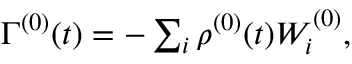<formula> <loc_0><loc_0><loc_500><loc_500>\begin{array} { r } { \Gamma ^ { ( 0 ) } ( t ) = - \sum _ { i } \rho ^ { ( 0 ) } ( t ) W _ { i } ^ { ( 0 ) } , } \end{array}</formula> 